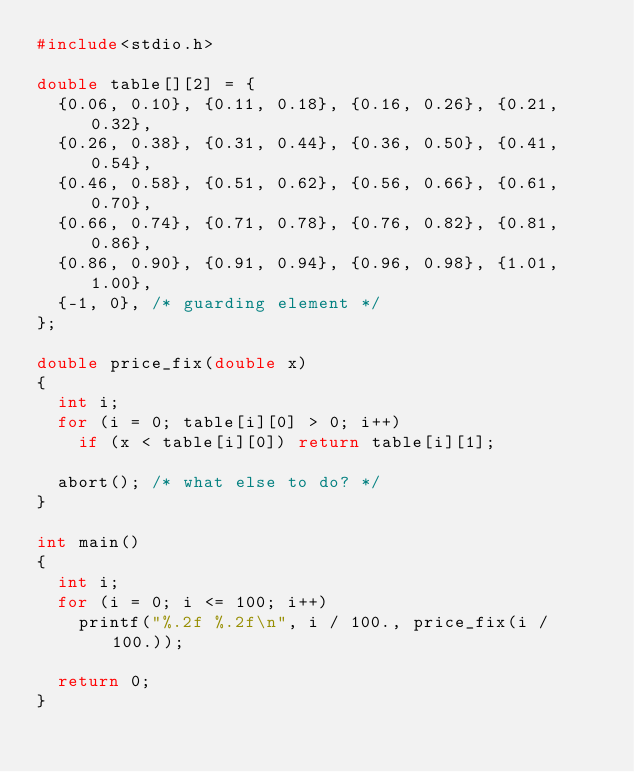<code> <loc_0><loc_0><loc_500><loc_500><_C_>#include<stdio.h>

double table[][2] = {
	{0.06, 0.10}, {0.11, 0.18}, {0.16, 0.26}, {0.21, 0.32},
	{0.26, 0.38}, {0.31, 0.44}, {0.36, 0.50}, {0.41, 0.54},
	{0.46, 0.58}, {0.51, 0.62}, {0.56, 0.66}, {0.61, 0.70},
	{0.66, 0.74}, {0.71, 0.78}, {0.76, 0.82}, {0.81, 0.86},
	{0.86, 0.90}, {0.91, 0.94}, {0.96, 0.98}, {1.01, 1.00},
	{-1, 0}, /* guarding element */
};

double price_fix(double x)
{
	int i;
	for (i = 0; table[i][0] > 0; i++)
		if (x < table[i][0]) return table[i][1];

	abort(); /* what else to do? */
}

int main()
{
	int i;
	for (i = 0; i <= 100; i++)
		printf("%.2f %.2f\n", i / 100., price_fix(i / 100.));

	return 0;
}
</code> 